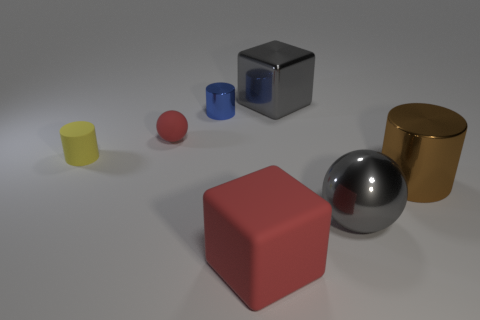Subtract all metallic cylinders. How many cylinders are left? 1 Subtract 1 cylinders. How many cylinders are left? 2 Add 1 small blue things. How many objects exist? 8 Subtract all spheres. How many objects are left? 5 Add 7 small brown shiny spheres. How many small brown shiny spheres exist? 7 Subtract 0 green blocks. How many objects are left? 7 Subtract all gray metal objects. Subtract all red cubes. How many objects are left? 4 Add 4 matte cylinders. How many matte cylinders are left? 5 